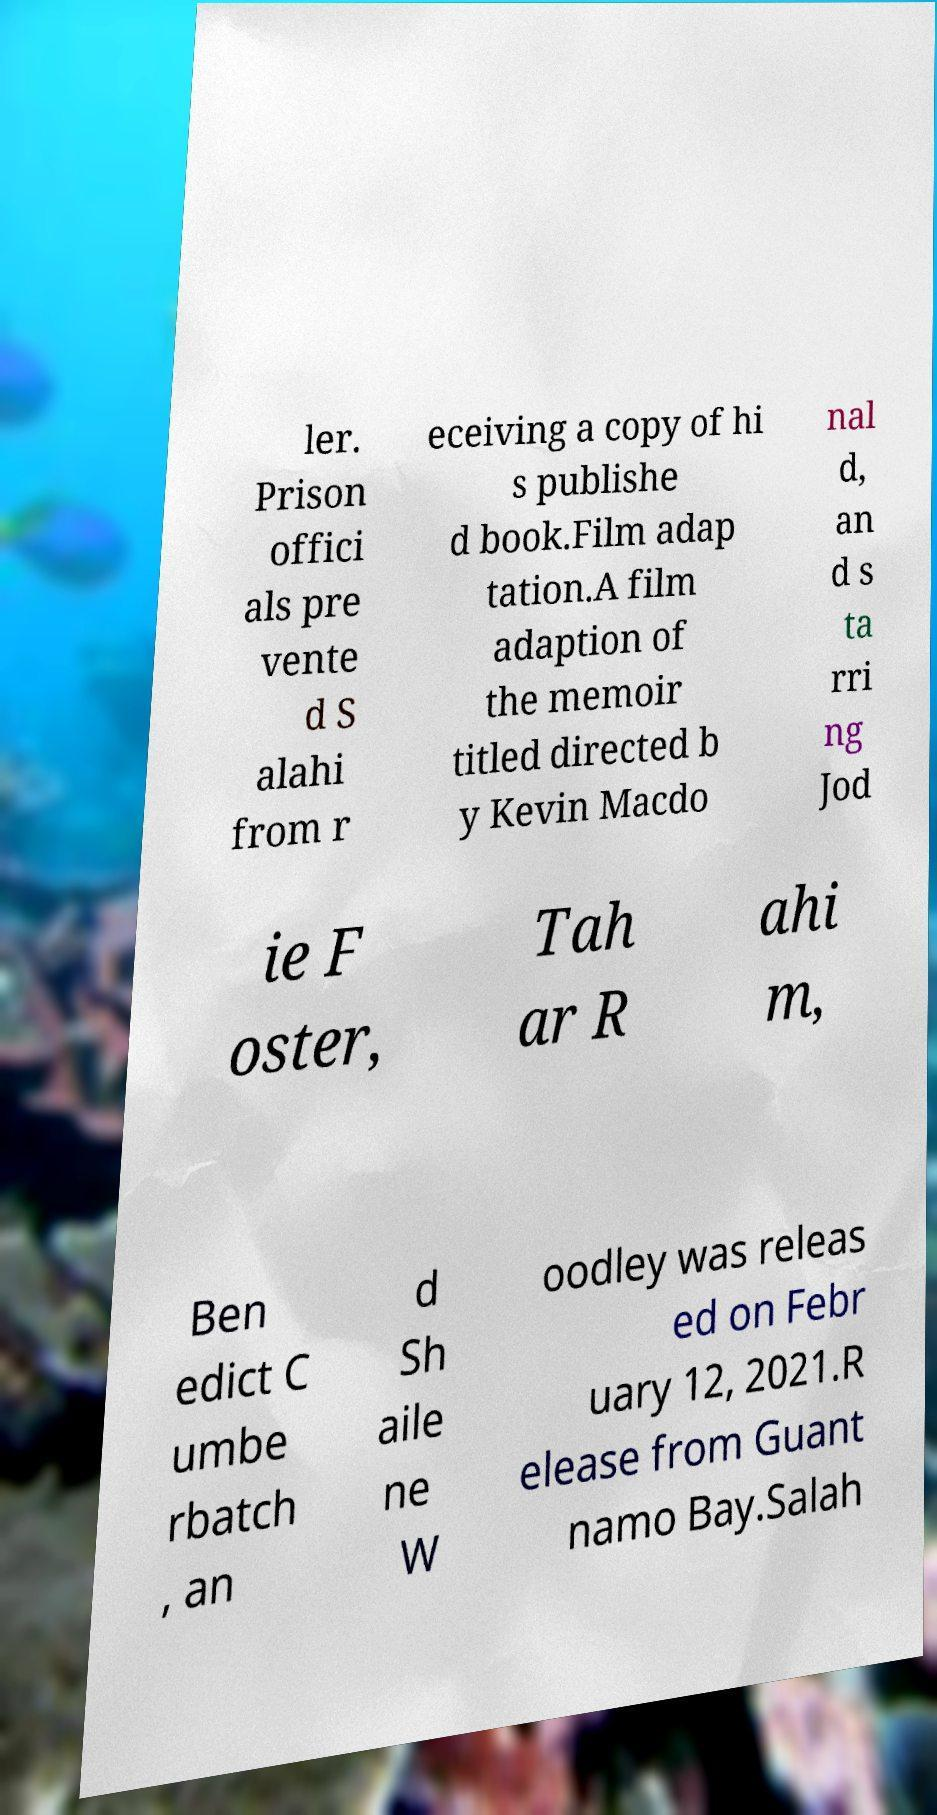I need the written content from this picture converted into text. Can you do that? ler. Prison offici als pre vente d S alahi from r eceiving a copy of hi s publishe d book.Film adap tation.A film adaption of the memoir titled directed b y Kevin Macdo nal d, an d s ta rri ng Jod ie F oster, Tah ar R ahi m, Ben edict C umbe rbatch , an d Sh aile ne W oodley was releas ed on Febr uary 12, 2021.R elease from Guant namo Bay.Salah 